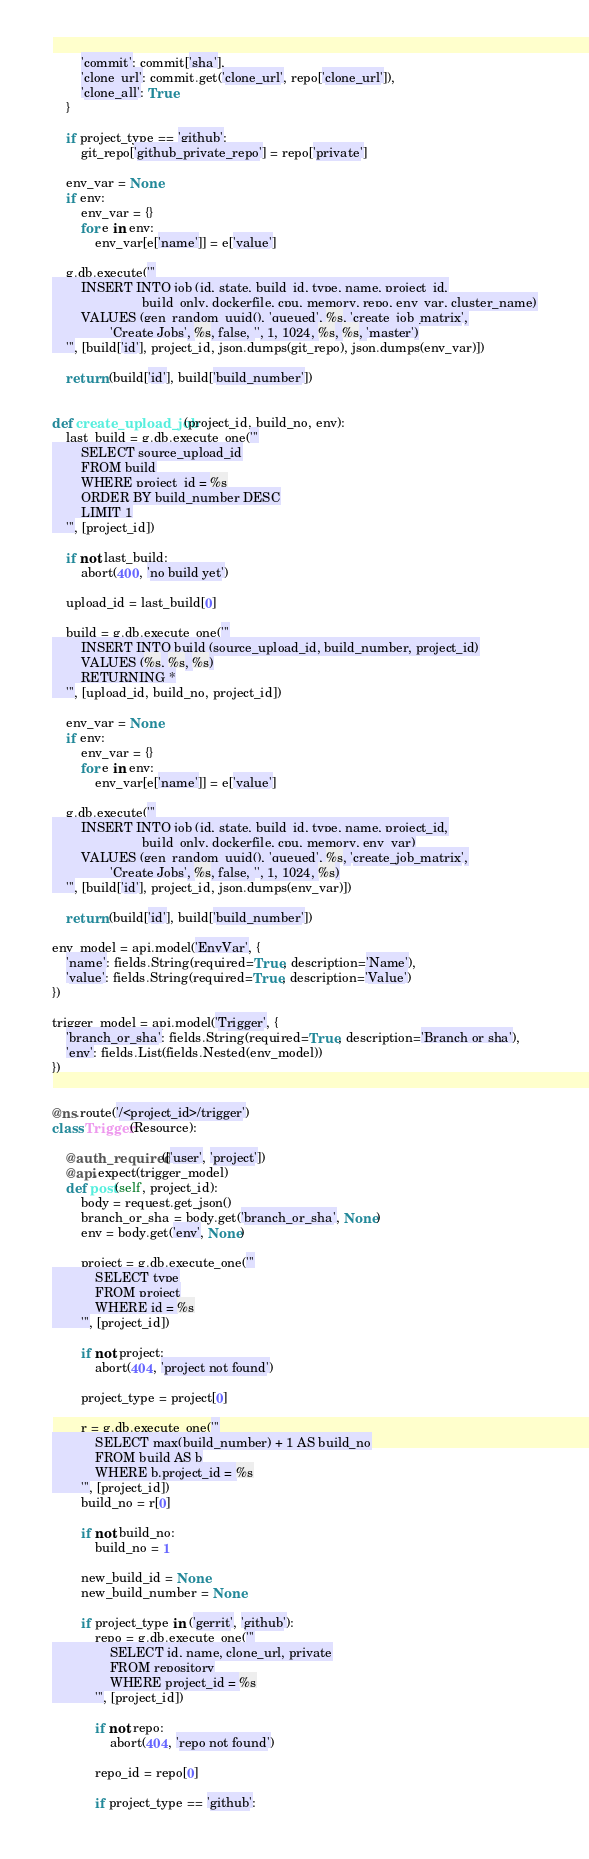Convert code to text. <code><loc_0><loc_0><loc_500><loc_500><_Python_>        'commit': commit['sha'],
        'clone_url': commit.get('clone_url', repo['clone_url']),
        'clone_all': True
    }

    if project_type == 'github':
        git_repo['github_private_repo'] = repo['private']

    env_var = None
    if env:
        env_var = {}
        for e in env:
            env_var[e['name']] = e['value']

    g.db.execute('''
        INSERT INTO job (id, state, build_id, type, name, project_id,
                         build_only, dockerfile, cpu, memory, repo, env_var, cluster_name)
        VALUES (gen_random_uuid(), 'queued', %s, 'create_job_matrix',
                'Create Jobs', %s, false, '', 1, 1024, %s, %s, 'master')
    ''', [build['id'], project_id, json.dumps(git_repo), json.dumps(env_var)])

    return (build['id'], build['build_number'])


def create_upload_job(project_id, build_no, env):
    last_build = g.db.execute_one('''
        SELECT source_upload_id
        FROM build
        WHERE project_id = %s
        ORDER BY build_number DESC
        LIMIT 1
    ''', [project_id])

    if not last_build:
        abort(400, 'no build yet')

    upload_id = last_build[0]

    build = g.db.execute_one('''
        INSERT INTO build (source_upload_id, build_number, project_id)
        VALUES (%s, %s, %s)
        RETURNING *
    ''', [upload_id, build_no, project_id])

    env_var = None
    if env:
        env_var = {}
        for e in env:
            env_var[e['name']] = e['value']

    g.db.execute('''
        INSERT INTO job (id, state, build_id, type, name, project_id,
                         build_only, dockerfile, cpu, memory, env_var)
        VALUES (gen_random_uuid(), 'queued', %s, 'create_job_matrix',
                'Create Jobs', %s, false, '', 1, 1024, %s)
    ''', [build['id'], project_id, json.dumps(env_var)])

    return (build['id'], build['build_number'])

env_model = api.model('EnvVar', {
    'name': fields.String(required=True, description='Name'),
    'value': fields.String(required=True, description='Value')
})

trigger_model = api.model('Trigger', {
    'branch_or_sha': fields.String(required=True, description='Branch or sha'),
    'env': fields.List(fields.Nested(env_model))
})


@ns.route('/<project_id>/trigger')
class Trigger(Resource):

    @auth_required(['user', 'project'])
    @api.expect(trigger_model)
    def post(self, project_id):
        body = request.get_json()
        branch_or_sha = body.get('branch_or_sha', None)
        env = body.get('env', None)

        project = g.db.execute_one('''
            SELECT type
            FROM project
            WHERE id = %s
        ''', [project_id])

        if not project:
            abort(404, 'project not found')

        project_type = project[0]

        r = g.db.execute_one('''
            SELECT max(build_number) + 1 AS build_no
            FROM build AS b
            WHERE b.project_id = %s
        ''', [project_id])
        build_no = r[0]

        if not build_no:
            build_no = 1

        new_build_id = None
        new_build_number = None

        if project_type in ('gerrit', 'github'):
            repo = g.db.execute_one('''
                SELECT id, name, clone_url, private
                FROM repository
                WHERE project_id = %s
            ''', [project_id])

            if not repo:
                abort(404, 'repo not found')

            repo_id = repo[0]

            if project_type == 'github':</code> 